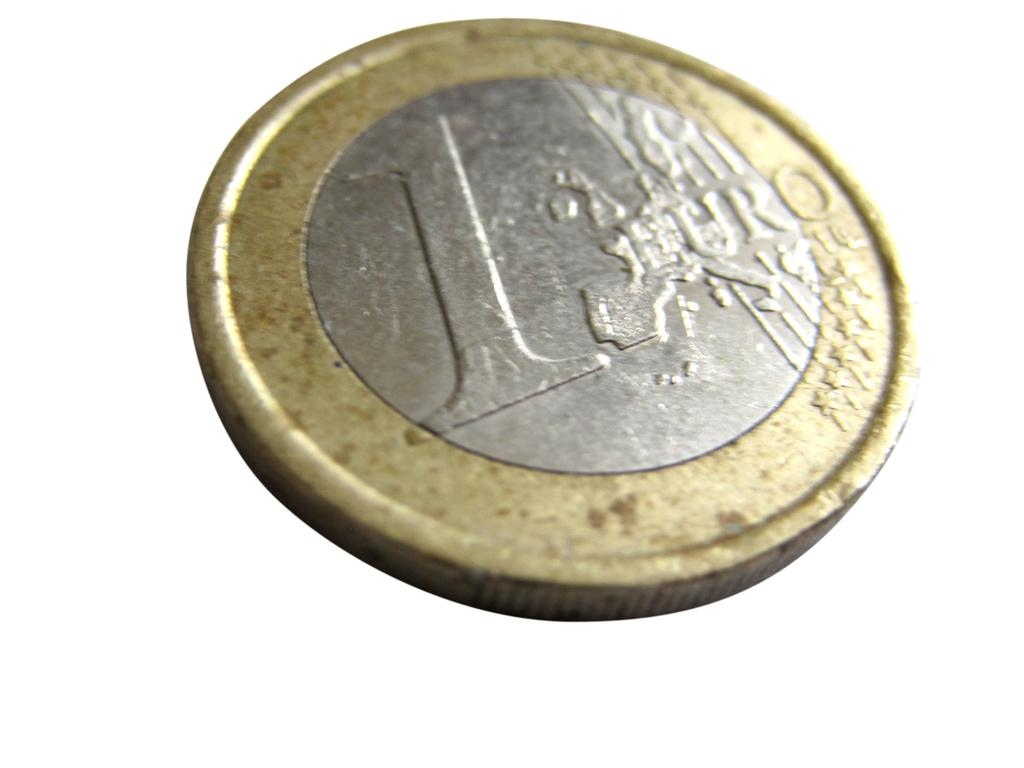<image>
Write a terse but informative summary of the picture. A coin that is both gold and silver colored and that is worth one Euro. 